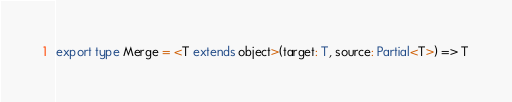<code> <loc_0><loc_0><loc_500><loc_500><_TypeScript_>
export type Merge = <T extends object>(target: T, source: Partial<T>) => T
</code> 